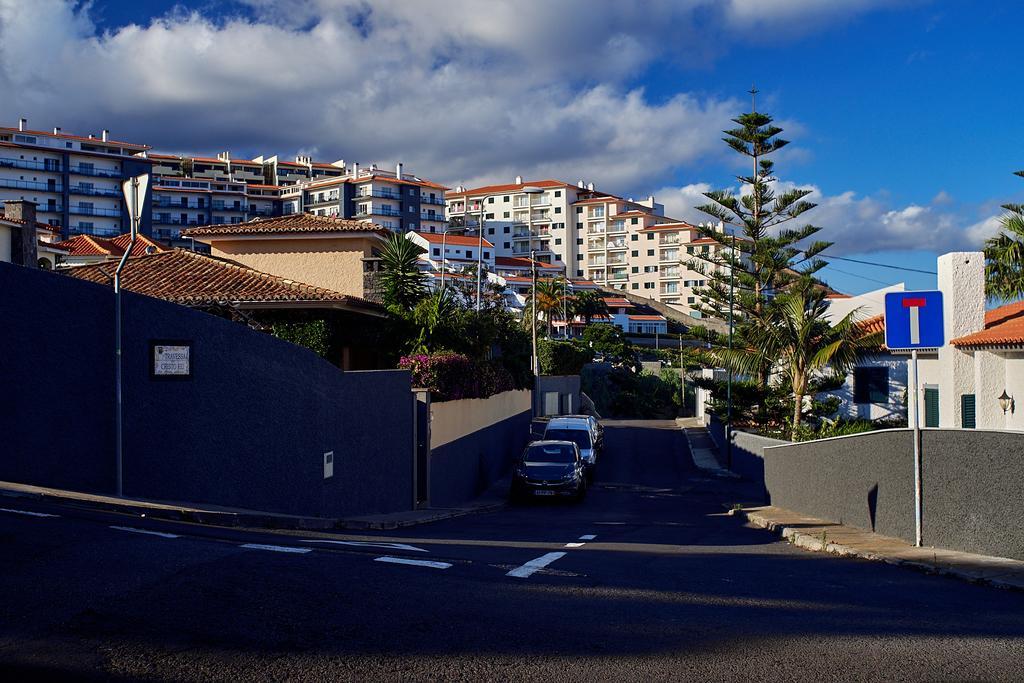Please provide a concise description of this image. In this image we can see some buildings, trees, poles, vehicles, road and other objects. At the top of the image there is the sky. At the bottom of the image there is the road. 